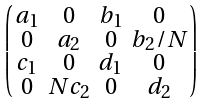<formula> <loc_0><loc_0><loc_500><loc_500>\begin{psmallmatrix} a _ { 1 } & 0 & b _ { 1 } & 0 \\ 0 & a _ { 2 } & 0 & b _ { 2 } / N \\ c _ { 1 } & 0 & d _ { 1 } & 0 \\ 0 & N c _ { 2 } & 0 & d _ { 2 } \end{psmallmatrix}</formula> 